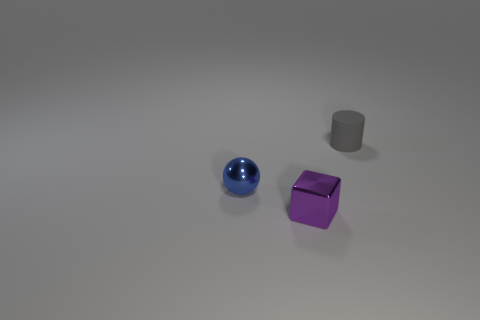Add 3 small blue matte blocks. How many objects exist? 6 Subtract all blocks. How many objects are left? 2 Subtract all big cyan rubber cylinders. Subtract all blue things. How many objects are left? 2 Add 2 gray cylinders. How many gray cylinders are left? 3 Add 2 red rubber things. How many red rubber things exist? 2 Subtract 0 green cylinders. How many objects are left? 3 Subtract all gray spheres. Subtract all red blocks. How many spheres are left? 1 